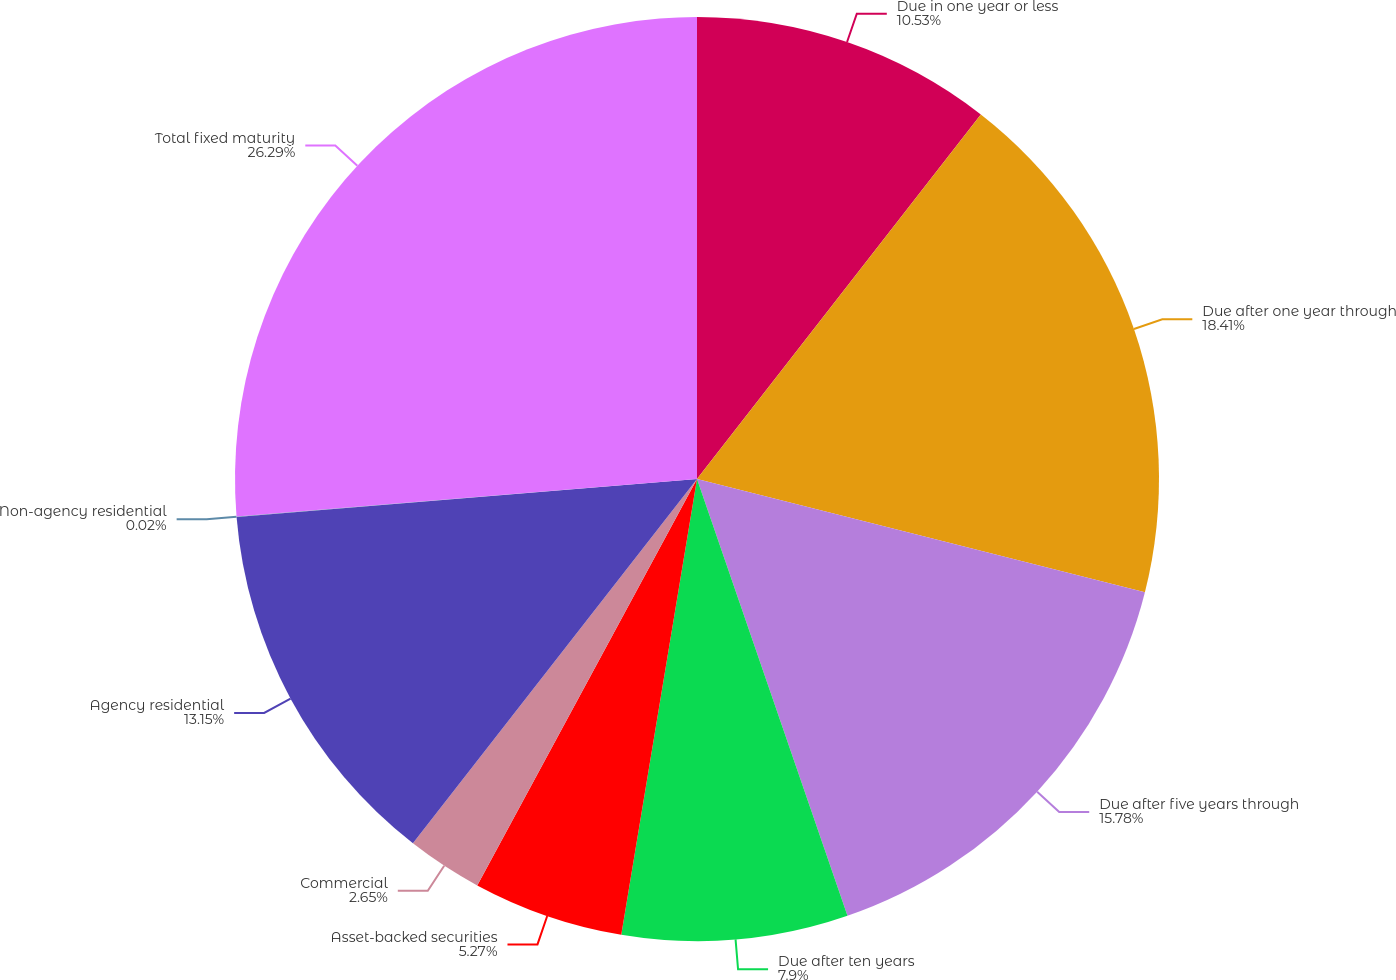Convert chart to OTSL. <chart><loc_0><loc_0><loc_500><loc_500><pie_chart><fcel>Due in one year or less<fcel>Due after one year through<fcel>Due after five years through<fcel>Due after ten years<fcel>Asset-backed securities<fcel>Commercial<fcel>Agency residential<fcel>Non-agency residential<fcel>Total fixed maturity<nl><fcel>10.53%<fcel>18.41%<fcel>15.78%<fcel>7.9%<fcel>5.27%<fcel>2.65%<fcel>13.15%<fcel>0.02%<fcel>26.29%<nl></chart> 